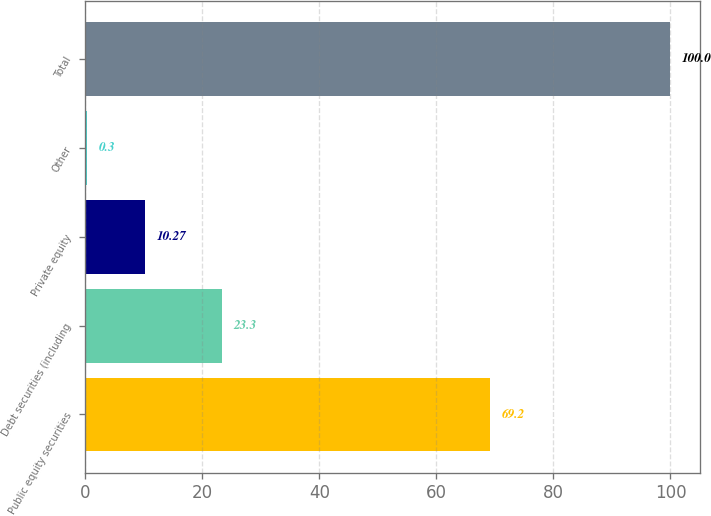Convert chart. <chart><loc_0><loc_0><loc_500><loc_500><bar_chart><fcel>Public equity securities<fcel>Debt securities (including<fcel>Private equity<fcel>Other<fcel>Total<nl><fcel>69.2<fcel>23.3<fcel>10.27<fcel>0.3<fcel>100<nl></chart> 